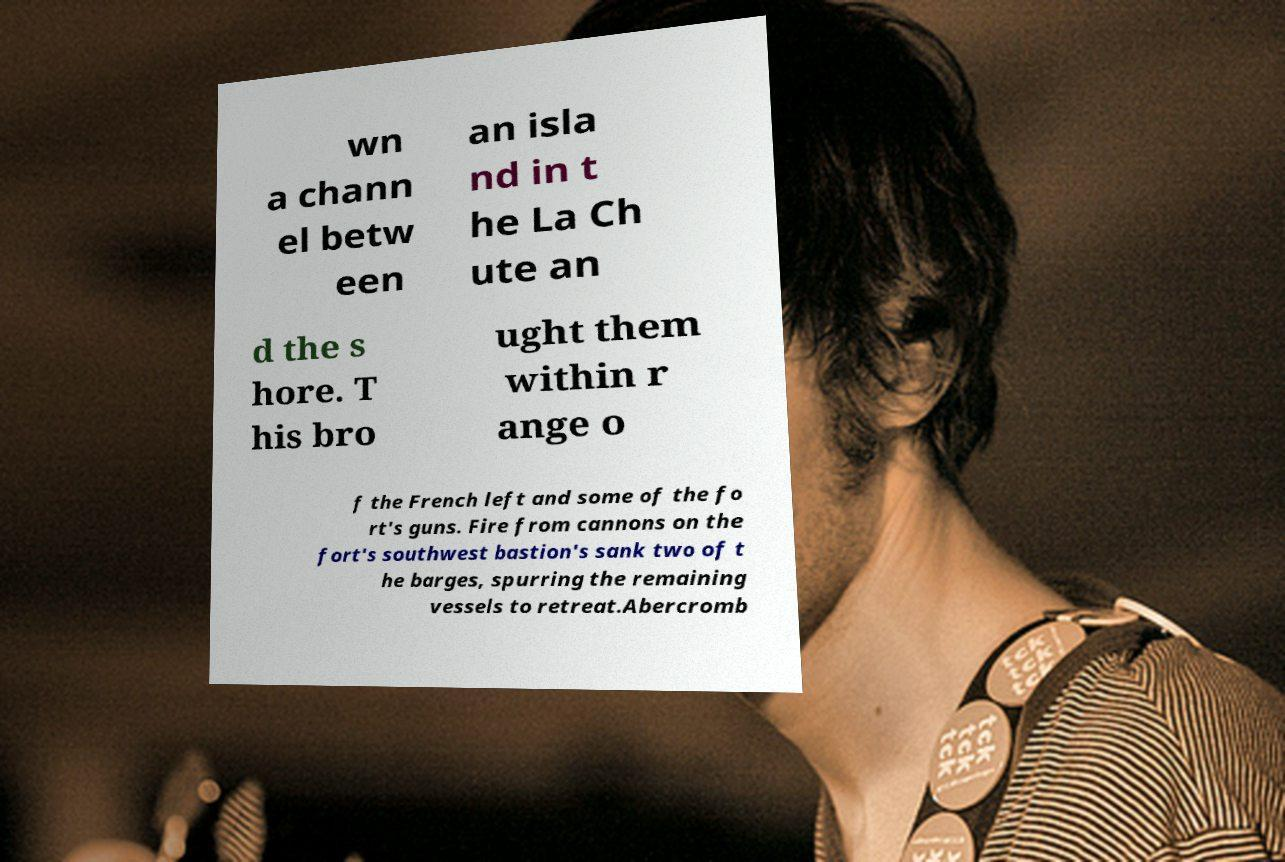Could you assist in decoding the text presented in this image and type it out clearly? wn a chann el betw een an isla nd in t he La Ch ute an d the s hore. T his bro ught them within r ange o f the French left and some of the fo rt's guns. Fire from cannons on the fort's southwest bastion's sank two of t he barges, spurring the remaining vessels to retreat.Abercromb 